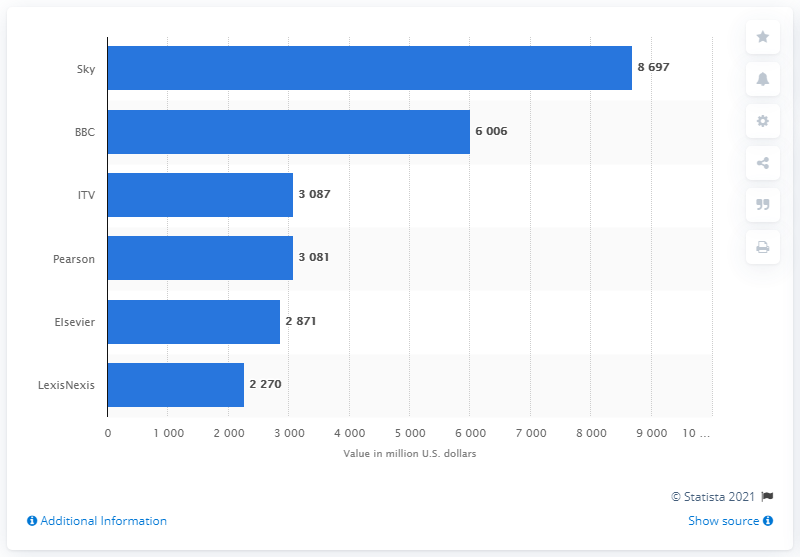Mention a couple of crucial points in this snapshot. In 2015, Sky was the most valuable brand in the UK media industry. In 2015, the BBC was the second most valuable brand in the UK media industry. As of December 31, 2014, the value of Sky was 8,697... 